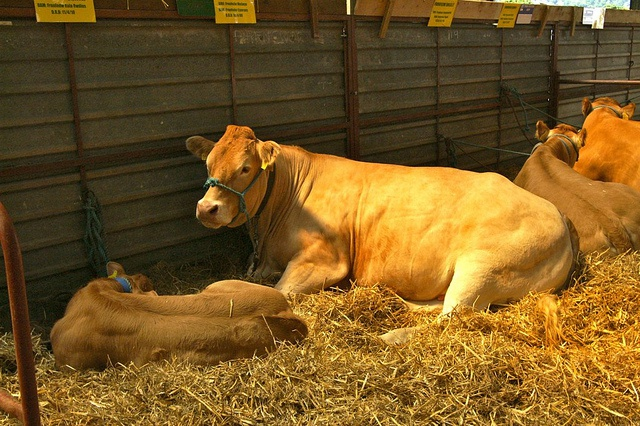Describe the objects in this image and their specific colors. I can see cow in black, gold, orange, and olive tones, cow in black, olive, and maroon tones, cow in black, olive, orange, and maroon tones, and cow in black, orange, brown, and maroon tones in this image. 